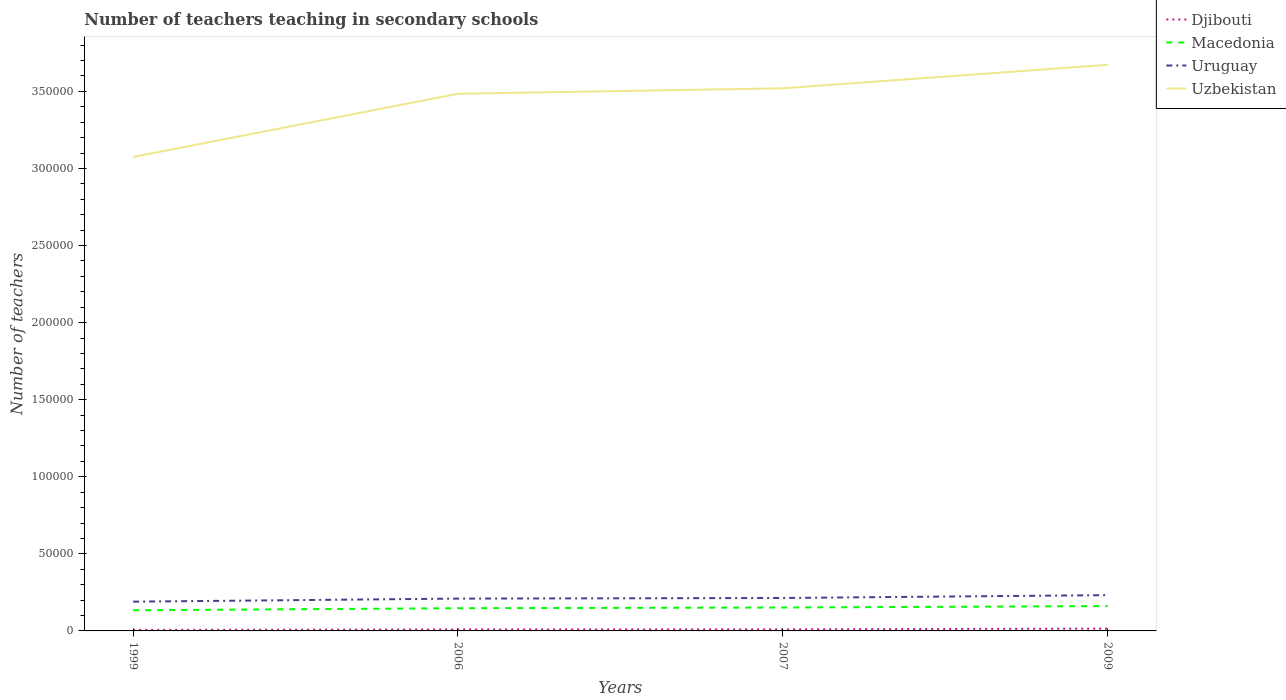Does the line corresponding to Uruguay intersect with the line corresponding to Djibouti?
Your response must be concise. No. Across all years, what is the maximum number of teachers teaching in secondary schools in Uzbekistan?
Offer a very short reply. 3.07e+05. In which year was the number of teachers teaching in secondary schools in Uruguay maximum?
Provide a short and direct response. 1999. What is the total number of teachers teaching in secondary schools in Uzbekistan in the graph?
Your response must be concise. -3556. What is the difference between the highest and the second highest number of teachers teaching in secondary schools in Djibouti?
Ensure brevity in your answer.  817. What is the difference between the highest and the lowest number of teachers teaching in secondary schools in Uzbekistan?
Give a very brief answer. 3. Is the number of teachers teaching in secondary schools in Macedonia strictly greater than the number of teachers teaching in secondary schools in Djibouti over the years?
Provide a succinct answer. No. How many lines are there?
Make the answer very short. 4. Are the values on the major ticks of Y-axis written in scientific E-notation?
Your response must be concise. No. Does the graph contain grids?
Keep it short and to the point. No. Where does the legend appear in the graph?
Make the answer very short. Top right. What is the title of the graph?
Your response must be concise. Number of teachers teaching in secondary schools. Does "Middle income" appear as one of the legend labels in the graph?
Offer a terse response. No. What is the label or title of the Y-axis?
Keep it short and to the point. Number of teachers. What is the Number of teachers in Djibouti in 1999?
Give a very brief answer. 680. What is the Number of teachers of Macedonia in 1999?
Keep it short and to the point. 1.34e+04. What is the Number of teachers of Uruguay in 1999?
Ensure brevity in your answer.  1.90e+04. What is the Number of teachers in Uzbekistan in 1999?
Keep it short and to the point. 3.07e+05. What is the Number of teachers in Djibouti in 2006?
Offer a very short reply. 967. What is the Number of teachers of Macedonia in 2006?
Your answer should be compact. 1.47e+04. What is the Number of teachers in Uruguay in 2006?
Give a very brief answer. 2.10e+04. What is the Number of teachers of Uzbekistan in 2006?
Keep it short and to the point. 3.48e+05. What is the Number of teachers in Djibouti in 2007?
Your answer should be compact. 1021. What is the Number of teachers in Macedonia in 2007?
Ensure brevity in your answer.  1.52e+04. What is the Number of teachers of Uruguay in 2007?
Provide a succinct answer. 2.14e+04. What is the Number of teachers of Uzbekistan in 2007?
Ensure brevity in your answer.  3.52e+05. What is the Number of teachers in Djibouti in 2009?
Offer a terse response. 1497. What is the Number of teachers of Macedonia in 2009?
Ensure brevity in your answer.  1.61e+04. What is the Number of teachers in Uruguay in 2009?
Offer a very short reply. 2.32e+04. What is the Number of teachers in Uzbekistan in 2009?
Keep it short and to the point. 3.67e+05. Across all years, what is the maximum Number of teachers in Djibouti?
Offer a terse response. 1497. Across all years, what is the maximum Number of teachers of Macedonia?
Ensure brevity in your answer.  1.61e+04. Across all years, what is the maximum Number of teachers of Uruguay?
Offer a very short reply. 2.32e+04. Across all years, what is the maximum Number of teachers in Uzbekistan?
Offer a terse response. 3.67e+05. Across all years, what is the minimum Number of teachers of Djibouti?
Make the answer very short. 680. Across all years, what is the minimum Number of teachers in Macedonia?
Your answer should be compact. 1.34e+04. Across all years, what is the minimum Number of teachers in Uruguay?
Ensure brevity in your answer.  1.90e+04. Across all years, what is the minimum Number of teachers in Uzbekistan?
Ensure brevity in your answer.  3.07e+05. What is the total Number of teachers of Djibouti in the graph?
Offer a very short reply. 4165. What is the total Number of teachers of Macedonia in the graph?
Ensure brevity in your answer.  5.94e+04. What is the total Number of teachers in Uruguay in the graph?
Give a very brief answer. 8.45e+04. What is the total Number of teachers of Uzbekistan in the graph?
Your response must be concise. 1.38e+06. What is the difference between the Number of teachers of Djibouti in 1999 and that in 2006?
Offer a terse response. -287. What is the difference between the Number of teachers in Macedonia in 1999 and that in 2006?
Provide a short and direct response. -1336. What is the difference between the Number of teachers in Uruguay in 1999 and that in 2006?
Offer a very short reply. -1978. What is the difference between the Number of teachers in Uzbekistan in 1999 and that in 2006?
Offer a very short reply. -4.10e+04. What is the difference between the Number of teachers in Djibouti in 1999 and that in 2007?
Your answer should be compact. -341. What is the difference between the Number of teachers in Macedonia in 1999 and that in 2007?
Ensure brevity in your answer.  -1794. What is the difference between the Number of teachers of Uruguay in 1999 and that in 2007?
Make the answer very short. -2383. What is the difference between the Number of teachers of Uzbekistan in 1999 and that in 2007?
Offer a very short reply. -4.45e+04. What is the difference between the Number of teachers of Djibouti in 1999 and that in 2009?
Offer a very short reply. -817. What is the difference between the Number of teachers of Macedonia in 1999 and that in 2009?
Ensure brevity in your answer.  -2719. What is the difference between the Number of teachers in Uruguay in 1999 and that in 2009?
Offer a terse response. -4230. What is the difference between the Number of teachers of Uzbekistan in 1999 and that in 2009?
Ensure brevity in your answer.  -5.98e+04. What is the difference between the Number of teachers in Djibouti in 2006 and that in 2007?
Your answer should be very brief. -54. What is the difference between the Number of teachers of Macedonia in 2006 and that in 2007?
Make the answer very short. -458. What is the difference between the Number of teachers in Uruguay in 2006 and that in 2007?
Offer a very short reply. -405. What is the difference between the Number of teachers of Uzbekistan in 2006 and that in 2007?
Offer a terse response. -3556. What is the difference between the Number of teachers of Djibouti in 2006 and that in 2009?
Provide a succinct answer. -530. What is the difference between the Number of teachers in Macedonia in 2006 and that in 2009?
Your answer should be very brief. -1383. What is the difference between the Number of teachers of Uruguay in 2006 and that in 2009?
Your answer should be very brief. -2252. What is the difference between the Number of teachers of Uzbekistan in 2006 and that in 2009?
Your answer should be compact. -1.88e+04. What is the difference between the Number of teachers in Djibouti in 2007 and that in 2009?
Ensure brevity in your answer.  -476. What is the difference between the Number of teachers of Macedonia in 2007 and that in 2009?
Your answer should be compact. -925. What is the difference between the Number of teachers of Uruguay in 2007 and that in 2009?
Ensure brevity in your answer.  -1847. What is the difference between the Number of teachers of Uzbekistan in 2007 and that in 2009?
Your answer should be very brief. -1.52e+04. What is the difference between the Number of teachers in Djibouti in 1999 and the Number of teachers in Macedonia in 2006?
Keep it short and to the point. -1.40e+04. What is the difference between the Number of teachers in Djibouti in 1999 and the Number of teachers in Uruguay in 2006?
Provide a short and direct response. -2.03e+04. What is the difference between the Number of teachers in Djibouti in 1999 and the Number of teachers in Uzbekistan in 2006?
Your response must be concise. -3.48e+05. What is the difference between the Number of teachers of Macedonia in 1999 and the Number of teachers of Uruguay in 2006?
Your answer should be very brief. -7573. What is the difference between the Number of teachers of Macedonia in 1999 and the Number of teachers of Uzbekistan in 2006?
Offer a terse response. -3.35e+05. What is the difference between the Number of teachers of Uruguay in 1999 and the Number of teachers of Uzbekistan in 2006?
Give a very brief answer. -3.29e+05. What is the difference between the Number of teachers of Djibouti in 1999 and the Number of teachers of Macedonia in 2007?
Give a very brief answer. -1.45e+04. What is the difference between the Number of teachers of Djibouti in 1999 and the Number of teachers of Uruguay in 2007?
Give a very brief answer. -2.07e+04. What is the difference between the Number of teachers of Djibouti in 1999 and the Number of teachers of Uzbekistan in 2007?
Your answer should be compact. -3.51e+05. What is the difference between the Number of teachers in Macedonia in 1999 and the Number of teachers in Uruguay in 2007?
Your response must be concise. -7978. What is the difference between the Number of teachers of Macedonia in 1999 and the Number of teachers of Uzbekistan in 2007?
Make the answer very short. -3.39e+05. What is the difference between the Number of teachers in Uruguay in 1999 and the Number of teachers in Uzbekistan in 2007?
Keep it short and to the point. -3.33e+05. What is the difference between the Number of teachers of Djibouti in 1999 and the Number of teachers of Macedonia in 2009?
Ensure brevity in your answer.  -1.54e+04. What is the difference between the Number of teachers in Djibouti in 1999 and the Number of teachers in Uruguay in 2009?
Offer a very short reply. -2.25e+04. What is the difference between the Number of teachers of Djibouti in 1999 and the Number of teachers of Uzbekistan in 2009?
Ensure brevity in your answer.  -3.67e+05. What is the difference between the Number of teachers in Macedonia in 1999 and the Number of teachers in Uruguay in 2009?
Give a very brief answer. -9825. What is the difference between the Number of teachers of Macedonia in 1999 and the Number of teachers of Uzbekistan in 2009?
Your answer should be compact. -3.54e+05. What is the difference between the Number of teachers of Uruguay in 1999 and the Number of teachers of Uzbekistan in 2009?
Your answer should be compact. -3.48e+05. What is the difference between the Number of teachers of Djibouti in 2006 and the Number of teachers of Macedonia in 2007?
Your answer should be very brief. -1.42e+04. What is the difference between the Number of teachers of Djibouti in 2006 and the Number of teachers of Uruguay in 2007?
Provide a short and direct response. -2.04e+04. What is the difference between the Number of teachers of Djibouti in 2006 and the Number of teachers of Uzbekistan in 2007?
Offer a very short reply. -3.51e+05. What is the difference between the Number of teachers of Macedonia in 2006 and the Number of teachers of Uruguay in 2007?
Offer a terse response. -6642. What is the difference between the Number of teachers in Macedonia in 2006 and the Number of teachers in Uzbekistan in 2007?
Keep it short and to the point. -3.37e+05. What is the difference between the Number of teachers of Uruguay in 2006 and the Number of teachers of Uzbekistan in 2007?
Your response must be concise. -3.31e+05. What is the difference between the Number of teachers of Djibouti in 2006 and the Number of teachers of Macedonia in 2009?
Provide a short and direct response. -1.51e+04. What is the difference between the Number of teachers in Djibouti in 2006 and the Number of teachers in Uruguay in 2009?
Your answer should be compact. -2.22e+04. What is the difference between the Number of teachers of Djibouti in 2006 and the Number of teachers of Uzbekistan in 2009?
Give a very brief answer. -3.66e+05. What is the difference between the Number of teachers in Macedonia in 2006 and the Number of teachers in Uruguay in 2009?
Make the answer very short. -8489. What is the difference between the Number of teachers in Macedonia in 2006 and the Number of teachers in Uzbekistan in 2009?
Your answer should be compact. -3.52e+05. What is the difference between the Number of teachers in Uruguay in 2006 and the Number of teachers in Uzbekistan in 2009?
Offer a terse response. -3.46e+05. What is the difference between the Number of teachers in Djibouti in 2007 and the Number of teachers in Macedonia in 2009?
Provide a succinct answer. -1.51e+04. What is the difference between the Number of teachers in Djibouti in 2007 and the Number of teachers in Uruguay in 2009?
Your answer should be very brief. -2.22e+04. What is the difference between the Number of teachers of Djibouti in 2007 and the Number of teachers of Uzbekistan in 2009?
Your answer should be very brief. -3.66e+05. What is the difference between the Number of teachers in Macedonia in 2007 and the Number of teachers in Uruguay in 2009?
Ensure brevity in your answer.  -8031. What is the difference between the Number of teachers in Macedonia in 2007 and the Number of teachers in Uzbekistan in 2009?
Provide a short and direct response. -3.52e+05. What is the difference between the Number of teachers of Uruguay in 2007 and the Number of teachers of Uzbekistan in 2009?
Give a very brief answer. -3.46e+05. What is the average Number of teachers in Djibouti per year?
Your response must be concise. 1041.25. What is the average Number of teachers in Macedonia per year?
Offer a terse response. 1.49e+04. What is the average Number of teachers in Uruguay per year?
Your response must be concise. 2.11e+04. What is the average Number of teachers in Uzbekistan per year?
Your answer should be compact. 3.44e+05. In the year 1999, what is the difference between the Number of teachers of Djibouti and Number of teachers of Macedonia?
Ensure brevity in your answer.  -1.27e+04. In the year 1999, what is the difference between the Number of teachers in Djibouti and Number of teachers in Uruguay?
Give a very brief answer. -1.83e+04. In the year 1999, what is the difference between the Number of teachers in Djibouti and Number of teachers in Uzbekistan?
Ensure brevity in your answer.  -3.07e+05. In the year 1999, what is the difference between the Number of teachers in Macedonia and Number of teachers in Uruguay?
Your answer should be very brief. -5595. In the year 1999, what is the difference between the Number of teachers in Macedonia and Number of teachers in Uzbekistan?
Offer a terse response. -2.94e+05. In the year 1999, what is the difference between the Number of teachers in Uruguay and Number of teachers in Uzbekistan?
Your answer should be compact. -2.88e+05. In the year 2006, what is the difference between the Number of teachers in Djibouti and Number of teachers in Macedonia?
Provide a succinct answer. -1.38e+04. In the year 2006, what is the difference between the Number of teachers of Djibouti and Number of teachers of Uruguay?
Make the answer very short. -2.00e+04. In the year 2006, what is the difference between the Number of teachers in Djibouti and Number of teachers in Uzbekistan?
Give a very brief answer. -3.47e+05. In the year 2006, what is the difference between the Number of teachers of Macedonia and Number of teachers of Uruguay?
Offer a terse response. -6237. In the year 2006, what is the difference between the Number of teachers in Macedonia and Number of teachers in Uzbekistan?
Your answer should be compact. -3.34e+05. In the year 2006, what is the difference between the Number of teachers of Uruguay and Number of teachers of Uzbekistan?
Your answer should be very brief. -3.27e+05. In the year 2007, what is the difference between the Number of teachers in Djibouti and Number of teachers in Macedonia?
Your answer should be very brief. -1.42e+04. In the year 2007, what is the difference between the Number of teachers of Djibouti and Number of teachers of Uruguay?
Make the answer very short. -2.03e+04. In the year 2007, what is the difference between the Number of teachers in Djibouti and Number of teachers in Uzbekistan?
Make the answer very short. -3.51e+05. In the year 2007, what is the difference between the Number of teachers of Macedonia and Number of teachers of Uruguay?
Give a very brief answer. -6184. In the year 2007, what is the difference between the Number of teachers in Macedonia and Number of teachers in Uzbekistan?
Make the answer very short. -3.37e+05. In the year 2007, what is the difference between the Number of teachers in Uruguay and Number of teachers in Uzbekistan?
Your response must be concise. -3.31e+05. In the year 2009, what is the difference between the Number of teachers in Djibouti and Number of teachers in Macedonia?
Ensure brevity in your answer.  -1.46e+04. In the year 2009, what is the difference between the Number of teachers in Djibouti and Number of teachers in Uruguay?
Your response must be concise. -2.17e+04. In the year 2009, what is the difference between the Number of teachers in Djibouti and Number of teachers in Uzbekistan?
Offer a terse response. -3.66e+05. In the year 2009, what is the difference between the Number of teachers in Macedonia and Number of teachers in Uruguay?
Offer a terse response. -7106. In the year 2009, what is the difference between the Number of teachers in Macedonia and Number of teachers in Uzbekistan?
Give a very brief answer. -3.51e+05. In the year 2009, what is the difference between the Number of teachers of Uruguay and Number of teachers of Uzbekistan?
Your answer should be very brief. -3.44e+05. What is the ratio of the Number of teachers of Djibouti in 1999 to that in 2006?
Your answer should be very brief. 0.7. What is the ratio of the Number of teachers in Macedonia in 1999 to that in 2006?
Your answer should be very brief. 0.91. What is the ratio of the Number of teachers of Uruguay in 1999 to that in 2006?
Give a very brief answer. 0.91. What is the ratio of the Number of teachers of Uzbekistan in 1999 to that in 2006?
Keep it short and to the point. 0.88. What is the ratio of the Number of teachers in Djibouti in 1999 to that in 2007?
Give a very brief answer. 0.67. What is the ratio of the Number of teachers in Macedonia in 1999 to that in 2007?
Provide a short and direct response. 0.88. What is the ratio of the Number of teachers in Uruguay in 1999 to that in 2007?
Give a very brief answer. 0.89. What is the ratio of the Number of teachers of Uzbekistan in 1999 to that in 2007?
Offer a terse response. 0.87. What is the ratio of the Number of teachers of Djibouti in 1999 to that in 2009?
Your response must be concise. 0.45. What is the ratio of the Number of teachers in Macedonia in 1999 to that in 2009?
Your response must be concise. 0.83. What is the ratio of the Number of teachers in Uruguay in 1999 to that in 2009?
Your answer should be compact. 0.82. What is the ratio of the Number of teachers of Uzbekistan in 1999 to that in 2009?
Your answer should be compact. 0.84. What is the ratio of the Number of teachers of Djibouti in 2006 to that in 2007?
Provide a short and direct response. 0.95. What is the ratio of the Number of teachers of Macedonia in 2006 to that in 2007?
Your answer should be very brief. 0.97. What is the ratio of the Number of teachers in Uruguay in 2006 to that in 2007?
Ensure brevity in your answer.  0.98. What is the ratio of the Number of teachers in Uzbekistan in 2006 to that in 2007?
Your answer should be compact. 0.99. What is the ratio of the Number of teachers of Djibouti in 2006 to that in 2009?
Provide a short and direct response. 0.65. What is the ratio of the Number of teachers in Macedonia in 2006 to that in 2009?
Keep it short and to the point. 0.91. What is the ratio of the Number of teachers in Uruguay in 2006 to that in 2009?
Provide a succinct answer. 0.9. What is the ratio of the Number of teachers in Uzbekistan in 2006 to that in 2009?
Your answer should be very brief. 0.95. What is the ratio of the Number of teachers of Djibouti in 2007 to that in 2009?
Give a very brief answer. 0.68. What is the ratio of the Number of teachers in Macedonia in 2007 to that in 2009?
Give a very brief answer. 0.94. What is the ratio of the Number of teachers in Uruguay in 2007 to that in 2009?
Offer a very short reply. 0.92. What is the ratio of the Number of teachers of Uzbekistan in 2007 to that in 2009?
Your answer should be compact. 0.96. What is the difference between the highest and the second highest Number of teachers in Djibouti?
Keep it short and to the point. 476. What is the difference between the highest and the second highest Number of teachers of Macedonia?
Provide a short and direct response. 925. What is the difference between the highest and the second highest Number of teachers of Uruguay?
Your answer should be very brief. 1847. What is the difference between the highest and the second highest Number of teachers of Uzbekistan?
Give a very brief answer. 1.52e+04. What is the difference between the highest and the lowest Number of teachers in Djibouti?
Offer a terse response. 817. What is the difference between the highest and the lowest Number of teachers of Macedonia?
Your answer should be compact. 2719. What is the difference between the highest and the lowest Number of teachers in Uruguay?
Offer a terse response. 4230. What is the difference between the highest and the lowest Number of teachers in Uzbekistan?
Provide a succinct answer. 5.98e+04. 